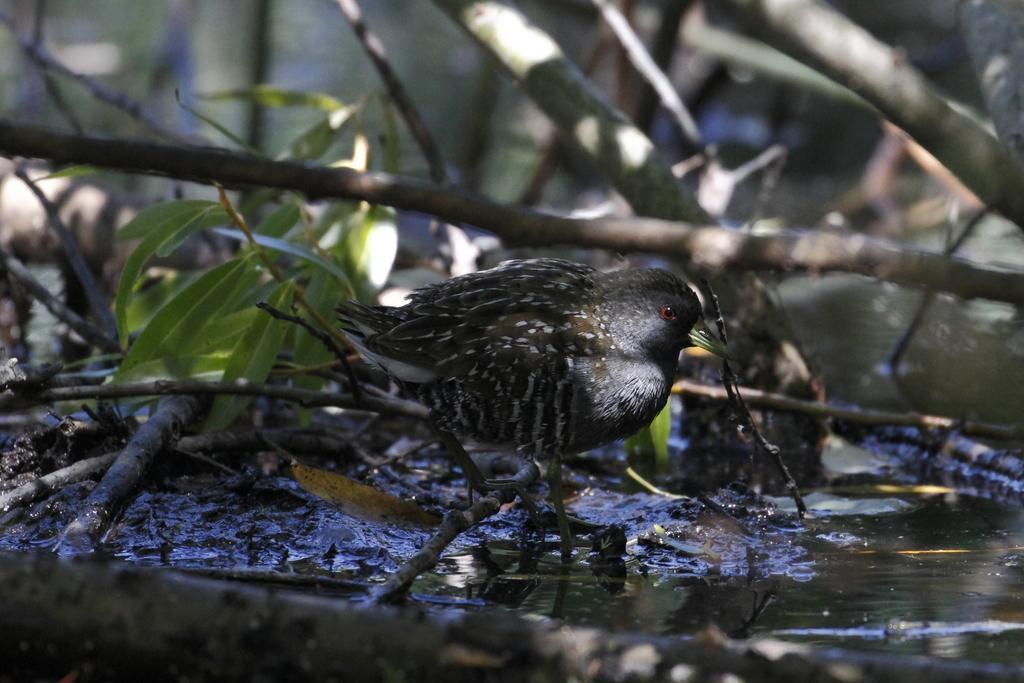Describe this image in one or two sentences. In this picture I can see a bird. There are leaves, branches and water. 